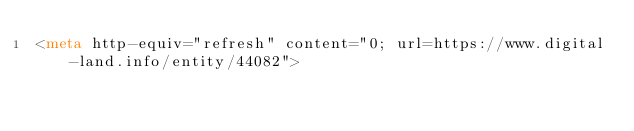<code> <loc_0><loc_0><loc_500><loc_500><_HTML_><meta http-equiv="refresh" content="0; url=https://www.digital-land.info/entity/44082"></code> 